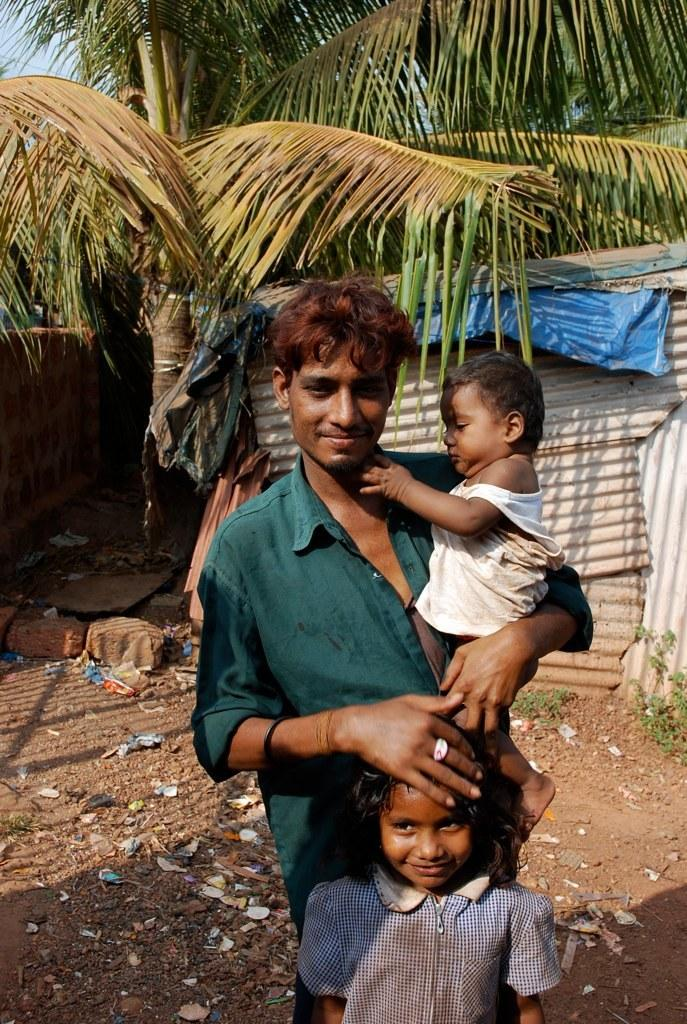Who is the main subject in the image? There is a man in the image. What is the man doing in the image? The man is holding a kid. Are there any other people in the image? Yes, there is a girl standing near the man. What can be seen in the background of the image? There is a small house, trees, and the sky visible in the background of the image. What type of seed is being planted in the square in the image? There is no square or seed present in the image; it features a man holding a kid, a girl standing nearby, and a background with a small house, trees, and the sky. 